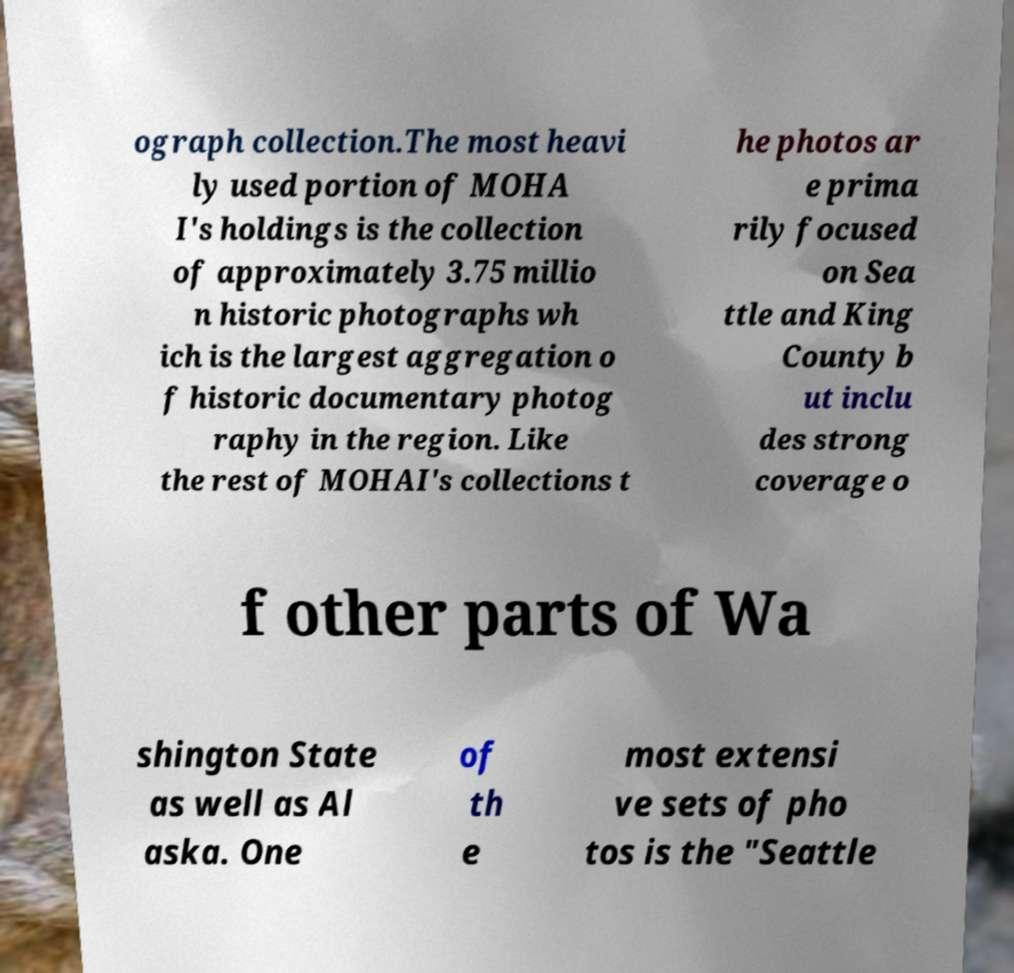Could you extract and type out the text from this image? ograph collection.The most heavi ly used portion of MOHA I's holdings is the collection of approximately 3.75 millio n historic photographs wh ich is the largest aggregation o f historic documentary photog raphy in the region. Like the rest of MOHAI's collections t he photos ar e prima rily focused on Sea ttle and King County b ut inclu des strong coverage o f other parts of Wa shington State as well as Al aska. One of th e most extensi ve sets of pho tos is the "Seattle 